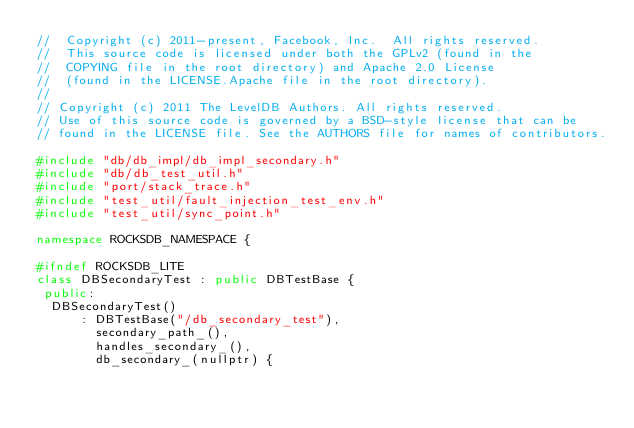Convert code to text. <code><loc_0><loc_0><loc_500><loc_500><_C++_>//  Copyright (c) 2011-present, Facebook, Inc.  All rights reserved.
//  This source code is licensed under both the GPLv2 (found in the
//  COPYING file in the root directory) and Apache 2.0 License
//  (found in the LICENSE.Apache file in the root directory).
//
// Copyright (c) 2011 The LevelDB Authors. All rights reserved.
// Use of this source code is governed by a BSD-style license that can be
// found in the LICENSE file. See the AUTHORS file for names of contributors.

#include "db/db_impl/db_impl_secondary.h"
#include "db/db_test_util.h"
#include "port/stack_trace.h"
#include "test_util/fault_injection_test_env.h"
#include "test_util/sync_point.h"

namespace ROCKSDB_NAMESPACE {

#ifndef ROCKSDB_LITE
class DBSecondaryTest : public DBTestBase {
 public:
  DBSecondaryTest()
      : DBTestBase("/db_secondary_test"),
        secondary_path_(),
        handles_secondary_(),
        db_secondary_(nullptr) {</code> 